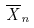<formula> <loc_0><loc_0><loc_500><loc_500>\overline { X } _ { n }</formula> 